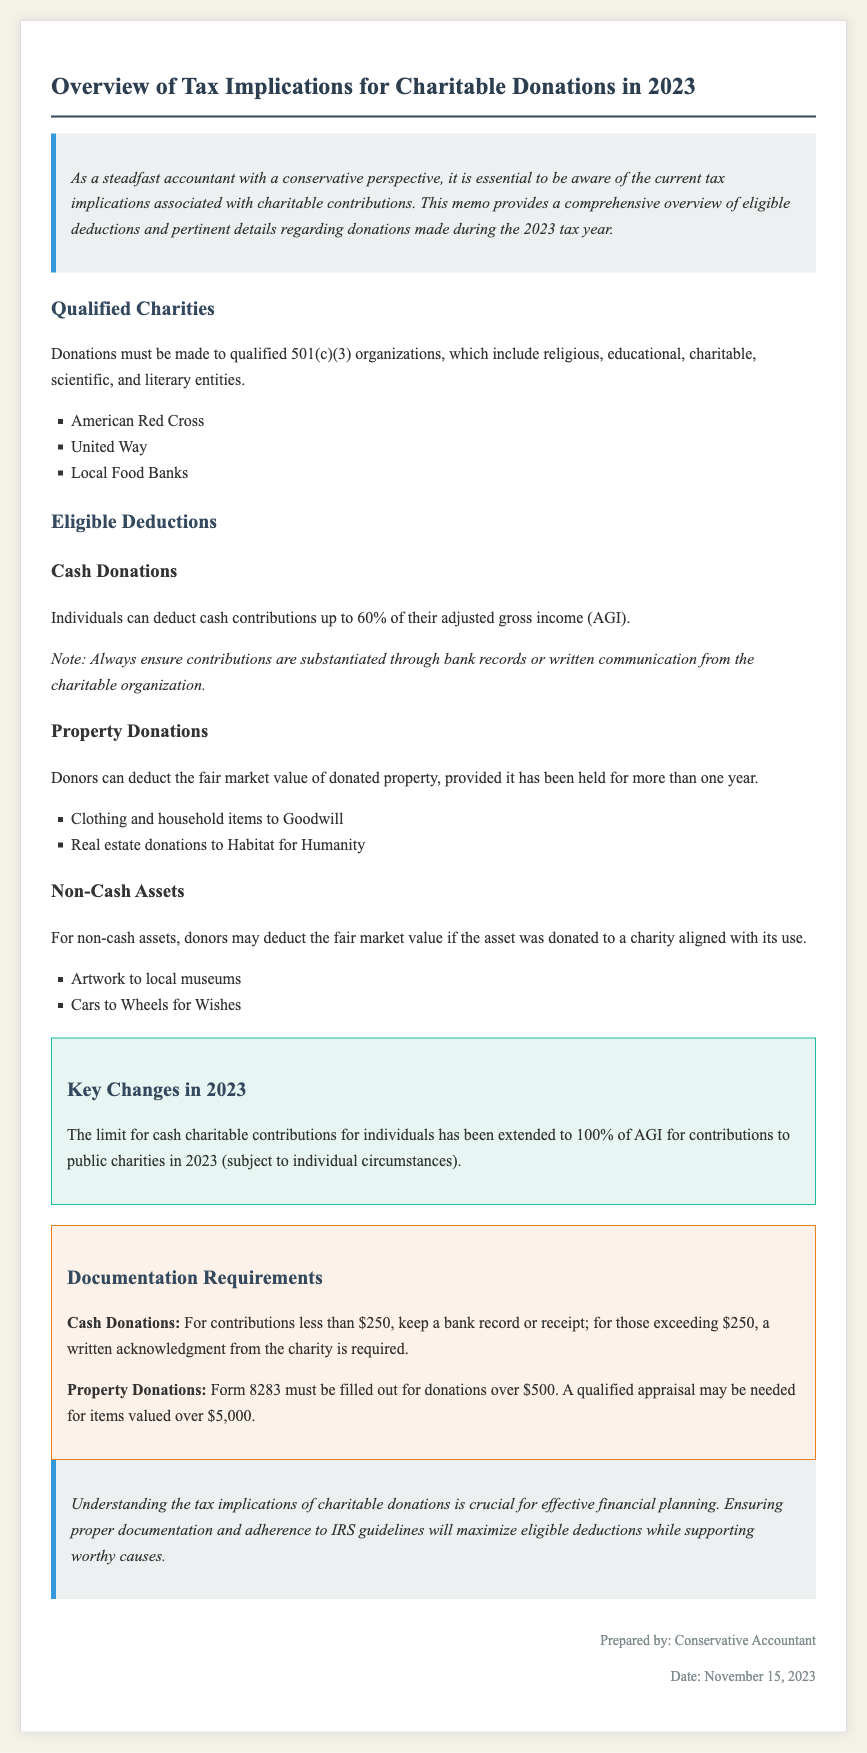What is the memo about? The memo provides an overview of tax implications for charitable donations made during 2023.
Answer: Tax Implications for Charitable Donations in 2023 What organizations qualify for donations? The document lists specific types of organizations that donations can be made to, including religious and charitable entities.
Answer: 501(c)(3) organizations What is the cash donation deduction limit for 2023? The memo states the deduction limit for cash contributions relative to adjusted gross income in 2023.
Answer: 100% of AGI What documentation is required for property donations over $500? The memo specifies the form that must be completed for higher-value property donations for tax purposes.
Answer: Form 8283 What is needed for cash donations over $250? The memo outlines what must be obtained for higher cash donations to substantiate the contribution.
Answer: A written acknowledgment from the charity Which charity is mentioned as an example for property donations? The document provides examples of charities to which property can be donated for deduction purposes.
Answer: Habitat for Humanity What is the key change regarding cash charitable contributions in 2023? The memo highlights the change in the cash contribution limit for individuals in the current tax year.
Answer: Extended to 100% of AGI What type of assets can provide a tax deduction when donated? The document categorizes different types of assets with respect to their eligibility for tax deductions.
Answer: Non-cash assets 